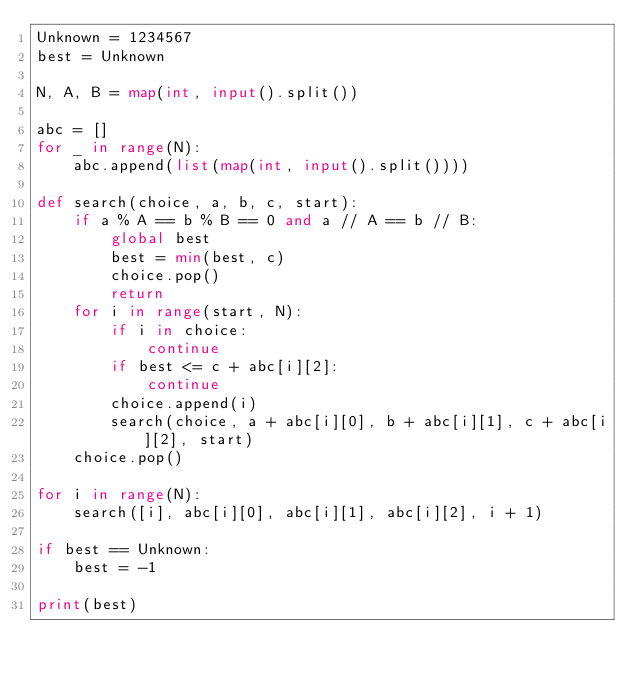Convert code to text. <code><loc_0><loc_0><loc_500><loc_500><_Python_>Unknown = 1234567
best = Unknown

N, A, B = map(int, input().split())

abc = []
for _ in range(N):
    abc.append(list(map(int, input().split())))

def search(choice, a, b, c, start):
    if a % A == b % B == 0 and a // A == b // B:
        global best
        best = min(best, c)
        choice.pop()
        return
    for i in range(start, N):
        if i in choice:
            continue
        if best <= c + abc[i][2]:
            continue
        choice.append(i)
        search(choice, a + abc[i][0], b + abc[i][1], c + abc[i][2], start)
    choice.pop()

for i in range(N):
    search([i], abc[i][0], abc[i][1], abc[i][2], i + 1)

if best == Unknown:
    best = -1

print(best)
</code> 